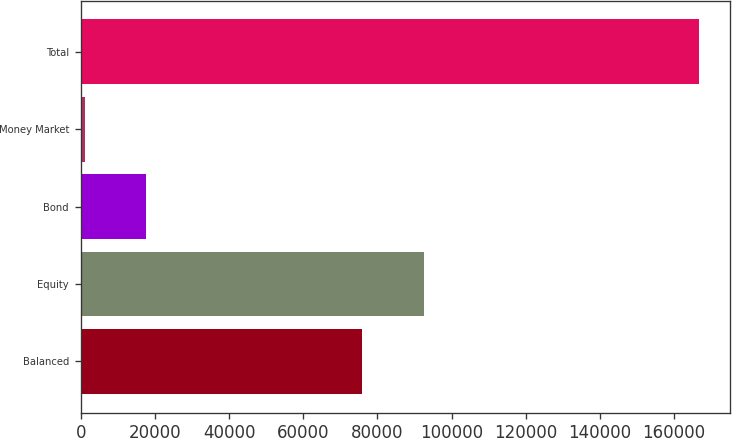Convert chart. <chart><loc_0><loc_0><loc_500><loc_500><bar_chart><fcel>Balanced<fcel>Equity<fcel>Bond<fcel>Money Market<fcel>Total<nl><fcel>75928<fcel>92487.6<fcel>17716.6<fcel>1157<fcel>166753<nl></chart> 